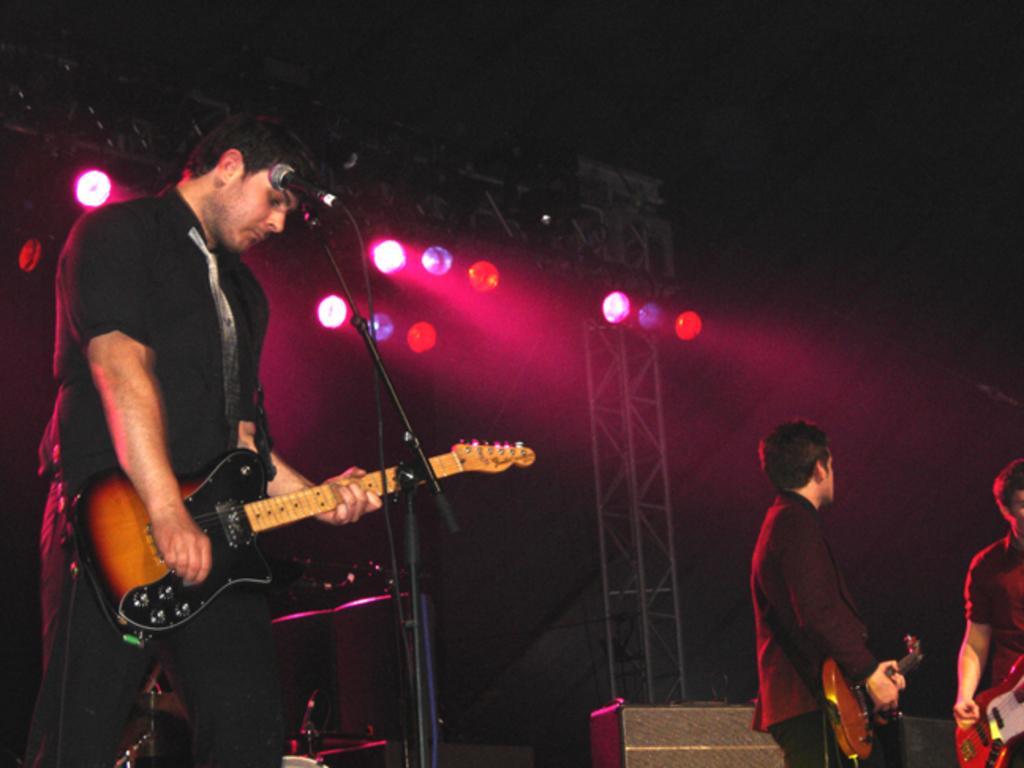Describe this image in one or two sentences. In this image i can see a playing guitar man there is a microphone in front of a man and right there are two other man standing at the back ground i can see few lights. 